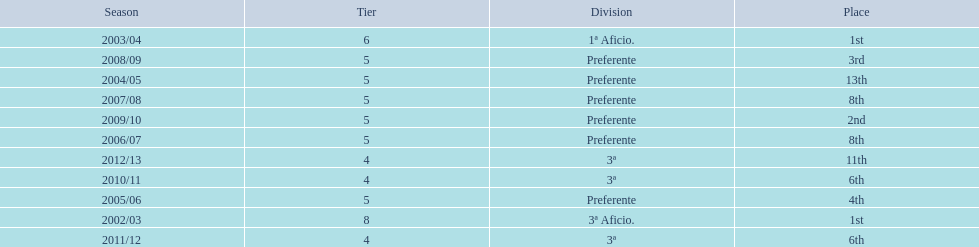What place did the team place in 2010/11? 6th. In what other year did they place 6th? 2011/12. 